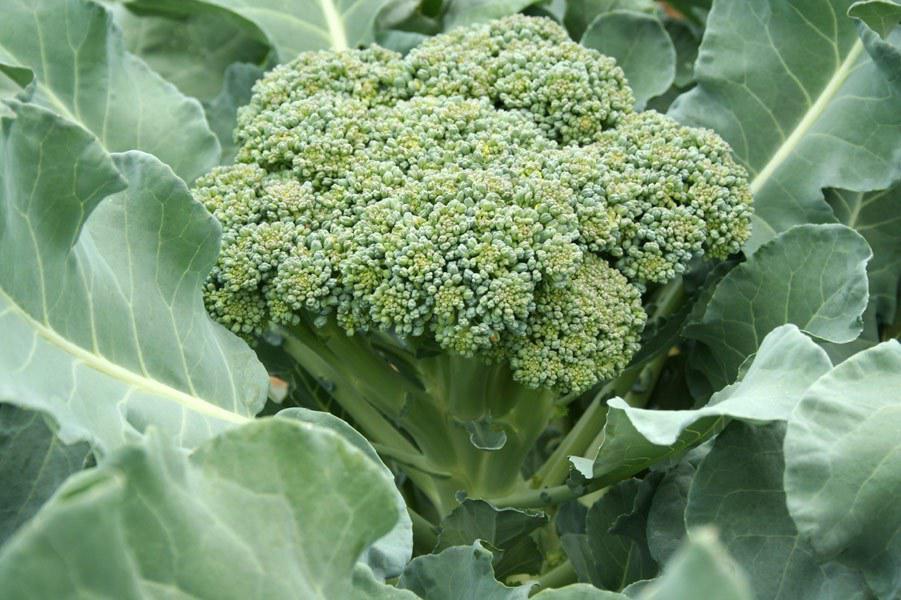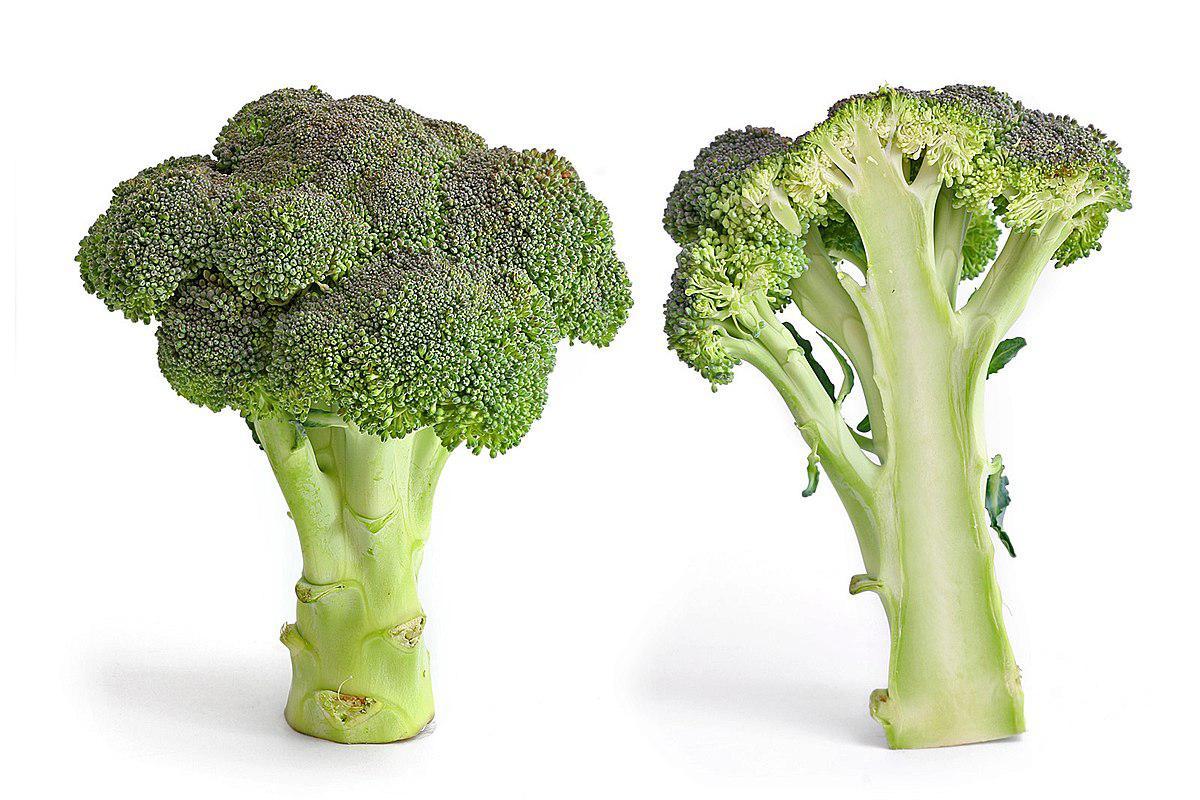The first image is the image on the left, the second image is the image on the right. For the images displayed, is the sentence "All images are on a plain white background." factually correct? Answer yes or no. No. The first image is the image on the left, the second image is the image on the right. For the images shown, is this caption "there are 3 bunches of broccoli against a white background" true? Answer yes or no. No. 